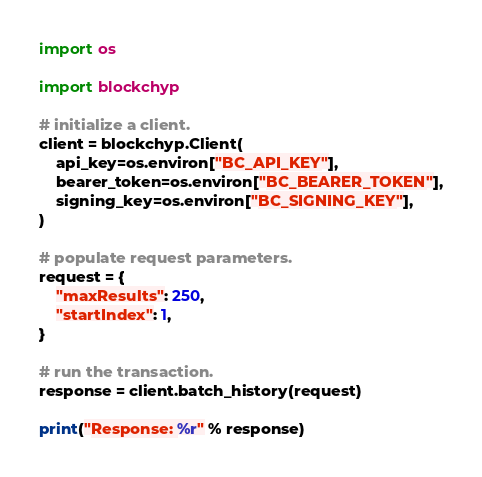<code> <loc_0><loc_0><loc_500><loc_500><_Python_>import os

import blockchyp

# initialize a client.
client = blockchyp.Client(
    api_key=os.environ["BC_API_KEY"],
    bearer_token=os.environ["BC_BEARER_TOKEN"],
    signing_key=os.environ["BC_SIGNING_KEY"],
)

# populate request parameters.
request = {
    "maxResults": 250,
    "startIndex": 1,
}

# run the transaction.
response = client.batch_history(request)

print("Response: %r" % response)
</code> 